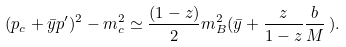Convert formula to latex. <formula><loc_0><loc_0><loc_500><loc_500>( p _ { c } + \bar { y } p ^ { \prime } ) ^ { 2 } - m _ { c } ^ { 2 } \simeq \frac { ( 1 - z ) } { 2 } m _ { B } ^ { 2 } ( \bar { y } + \frac { z } { 1 - z } \frac { b } { M } \, ) .</formula> 